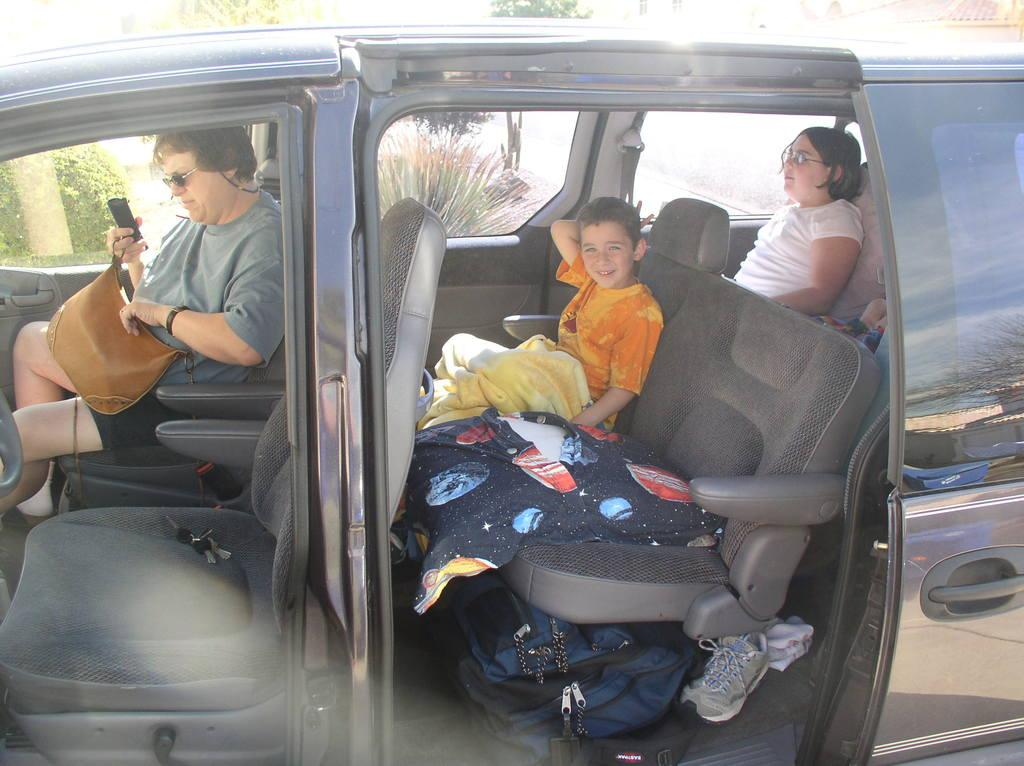What is happening inside the car in the image? There are people in the car. What can be seen on the floor of the car? There is luggage on the floor of the car. What is visible through the car window? Trees are visible through the car window. How many kittens are resting on the curve of the car in the image? There are no kittens or curves present in the image; it features people in a car with luggage and trees visible through the window. 